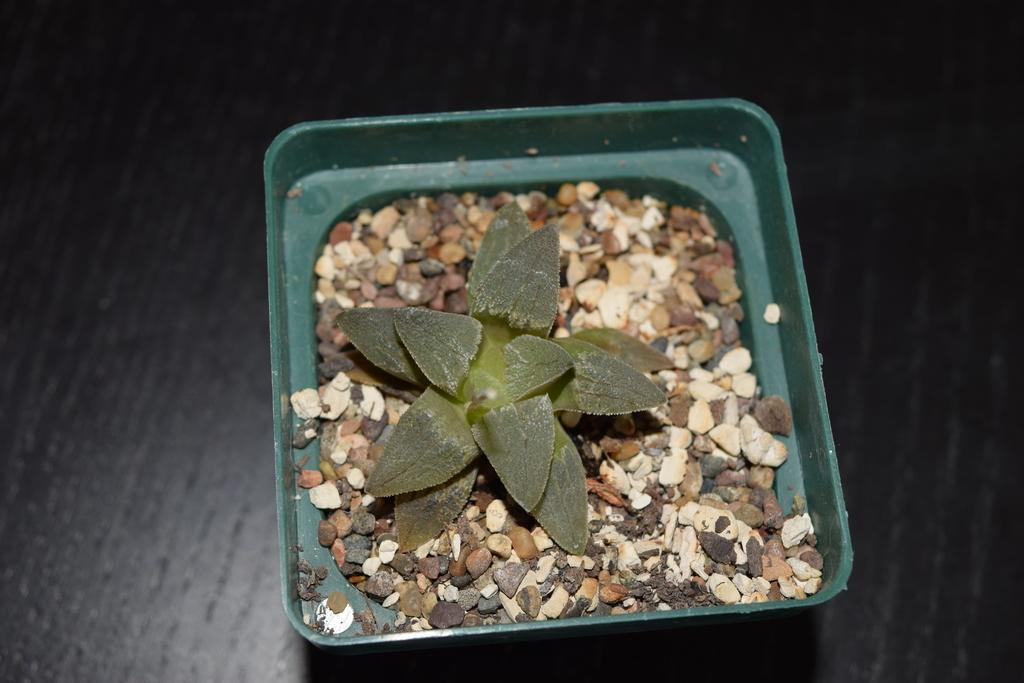What is the main subject in the center of the image? There is a plant in the center of the image. What else can be seen in the image besides the plant? There are stones in the image. How are the stones arranged or contained? The stones are in a pot. What is the color of the pot? The pot is green in color. What type of ice can be seen melting in the image? There is no ice present in the image; it features a plant, stones, and a green pot. 